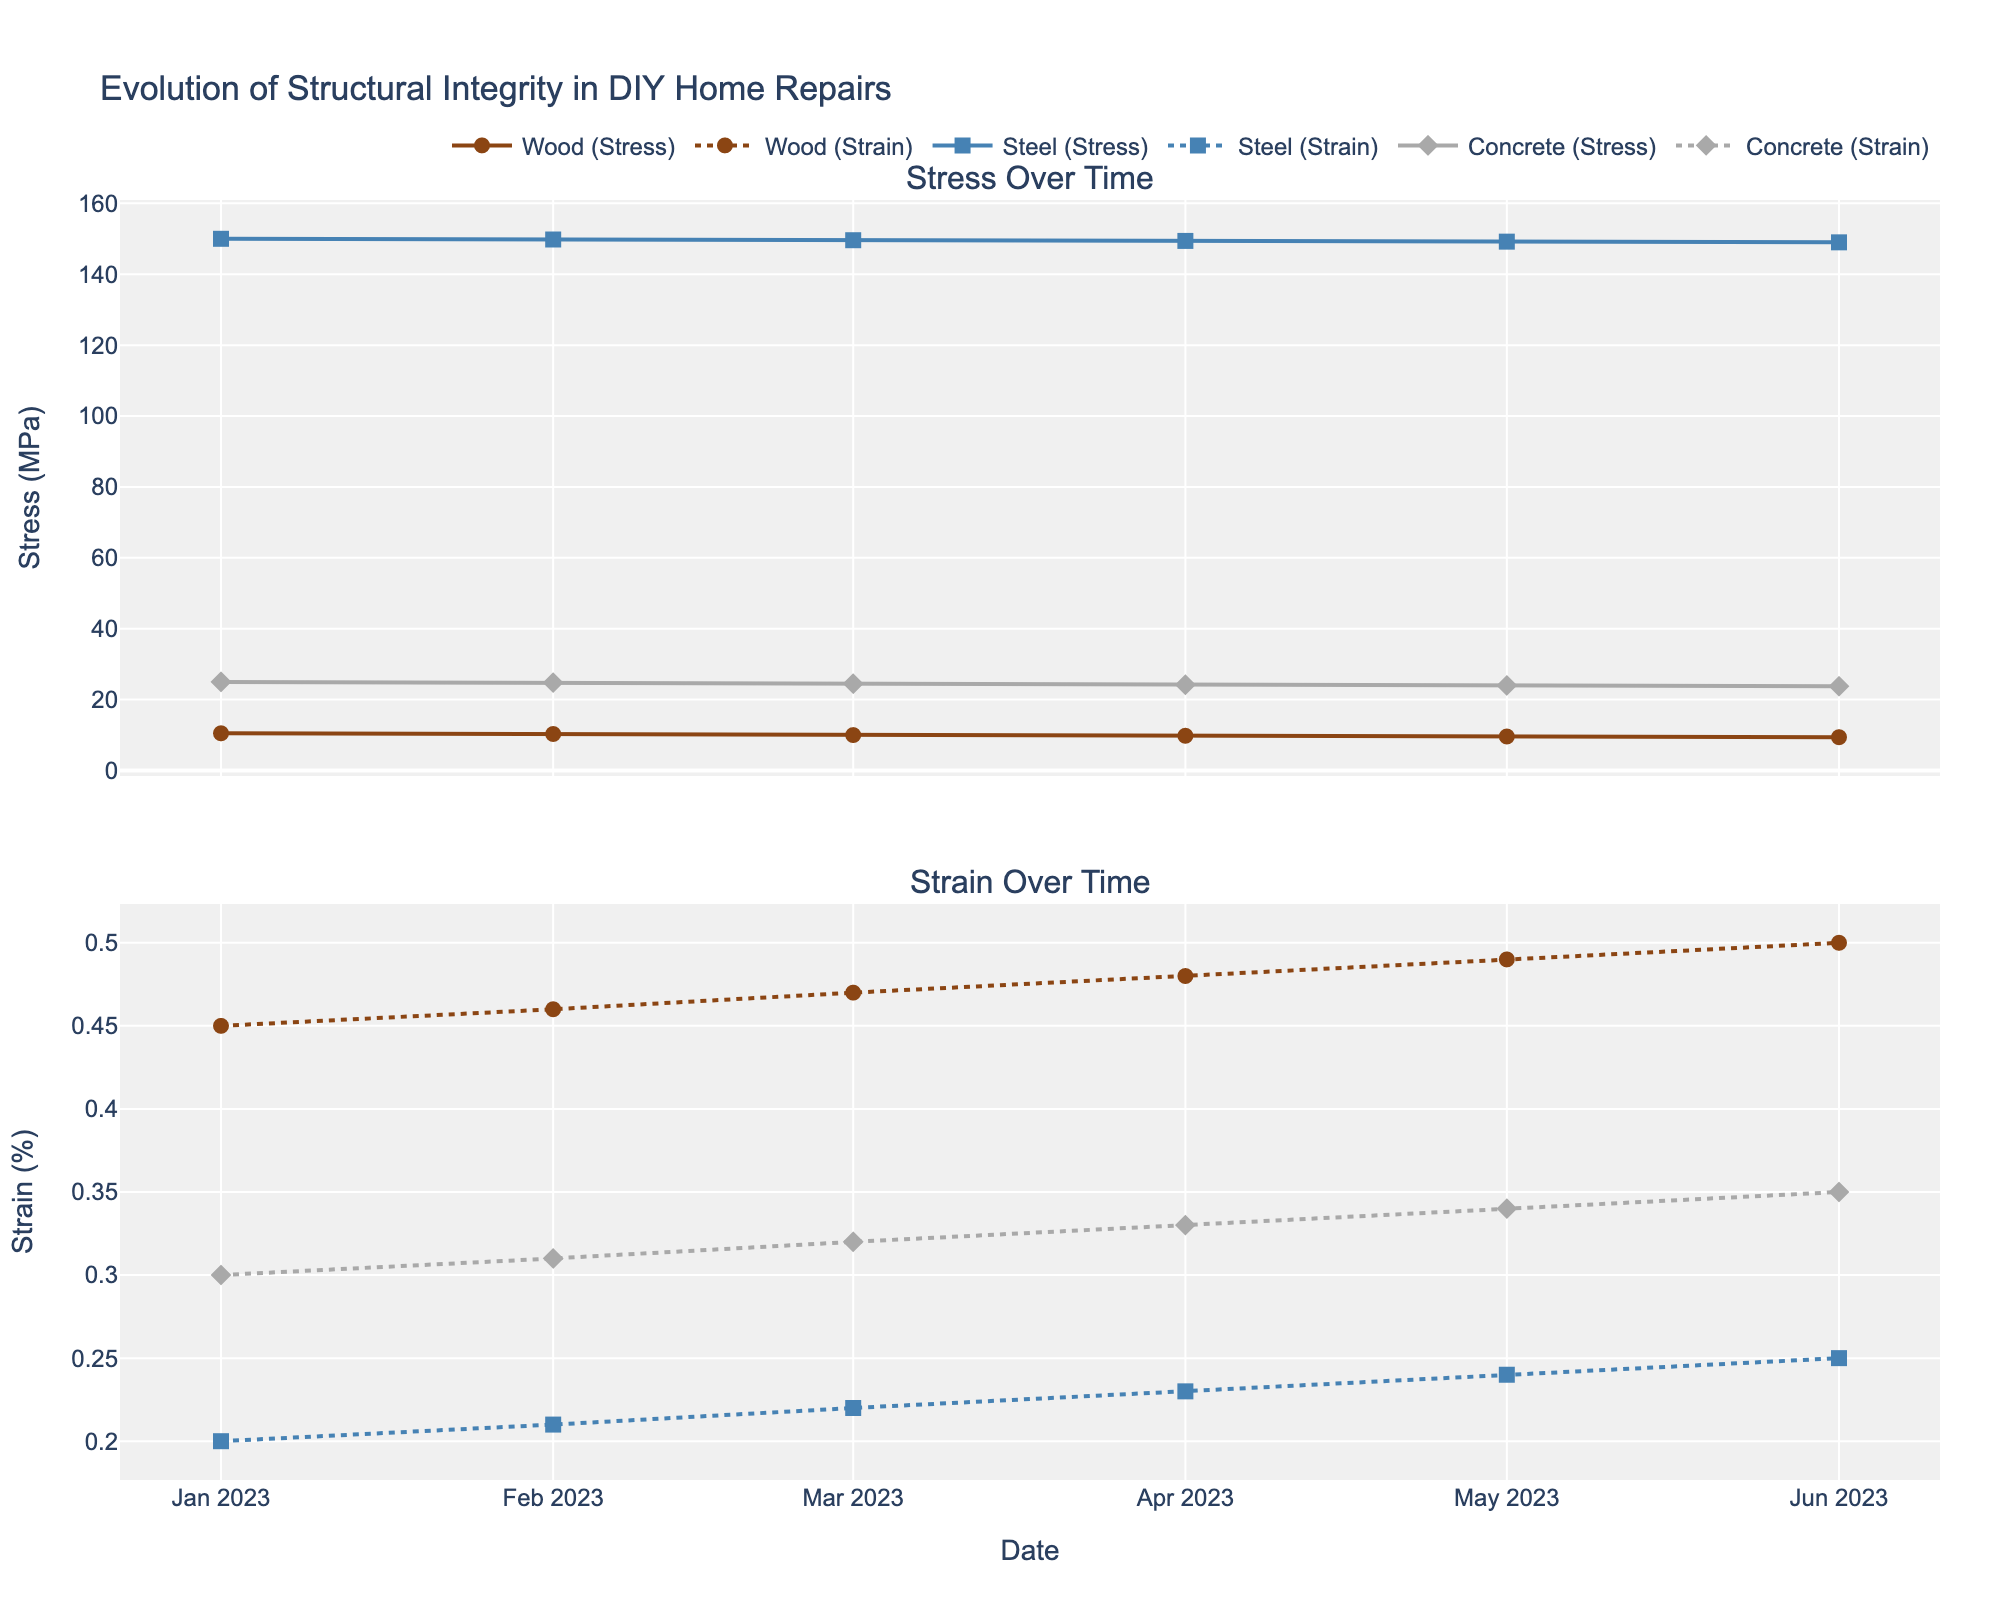what is the title of the plot? The title of the plot is visually shown at the top center of the figure, specifying what data the figure represents.
Answer: Evolution of Structural Integrity in DIY Home Repairs Which material has the highest stress value on 2023-03-01? By examining the point on the stress subplot for each material on 2023-03-01, it's clear the highest data point in terms of stress lies at 149.6 MPa for Steel.
Answer: Steel What trend do you observe in the stress values of Wood over time? Observing the stress plot for Wood, there is a downward trend. The stress starts at 10.5 MPa in January, decreasing to 9.4 MPa by June.
Answer: Decreasing Which material shows the greatest change in strain percentage over the recorded period? Checking the range of strain percentage by subtracting the minimum from the maximum for each material, we find:
Wood: 0.5 - 0.45 = 0.05
Steel: 0.25 - 0.20 = 0.05
Concrete: 0.35 - 0.30 = 0.05 
All three show the same change in percentage.
Answer: All materials Comparing the strain percentages between materials on 2023-04-01, which has the lowest value? By looking at the strain subplot on 2023-04-01 and comparing Wood (0.48%), Steel (0.23%), and Concrete (0.33%), Steel has the lowest strain percentage.
Answer: Steel What is the average stress value of Concrete across all the months? The stress values for Concrete are 25.0, 24.8, 24.5, 24.2, 24.0, and 23.8 MPa. Sum them to get 146.3 and divide by 6 (number of months) to get the average:
(25.0 + 24.8 + 24.5 + 24.2 + 24.0 + 23.8) / 6 = 24.38 MPa
Answer: 24.38 MPa What is the difference between the initial and final stress values for Steel? The initial stress value for Steel in January is 150.0 MPa, and the final value in June is 149.0 MPa. The difference is 150.0 - 149.0 = 1 MPa.
Answer: 1 MPa 